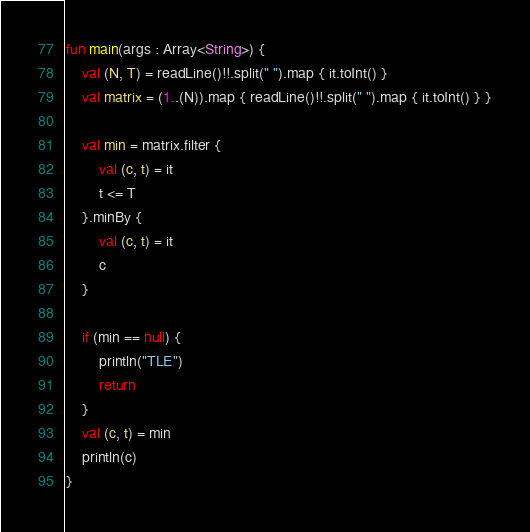<code> <loc_0><loc_0><loc_500><loc_500><_Kotlin_>fun main(args : Array<String>) {
    val (N, T) = readLine()!!.split(" ").map { it.toInt() }
    val matrix = (1..(N)).map { readLine()!!.split(" ").map { it.toInt() } }

    val min = matrix.filter {
        val (c, t) = it
        t <= T
    }.minBy {
        val (c, t) = it
        c
    }

    if (min == null) {
        println("TLE")
        return
    }
    val (c, t) = min
    println(c)
}</code> 